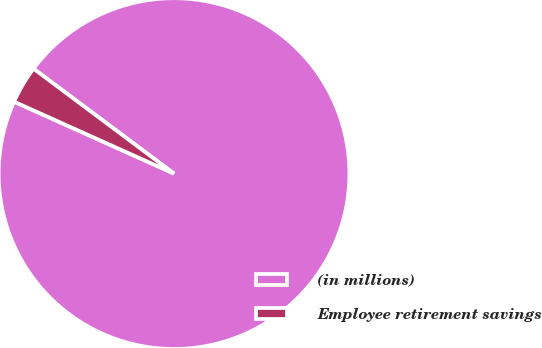<chart> <loc_0><loc_0><loc_500><loc_500><pie_chart><fcel>(in millions)<fcel>Employee retirement savings<nl><fcel>96.52%<fcel>3.48%<nl></chart> 